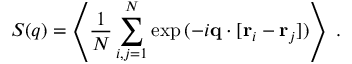Convert formula to latex. <formula><loc_0><loc_0><loc_500><loc_500>S ( q ) = \left \langle \frac { 1 } { N } \sum _ { \substack { i , j = 1 } } ^ { N } \exp { ( { - i q } \cdot [ { r } _ { i } - { r } _ { j } ] ) } \right \rangle \, .</formula> 